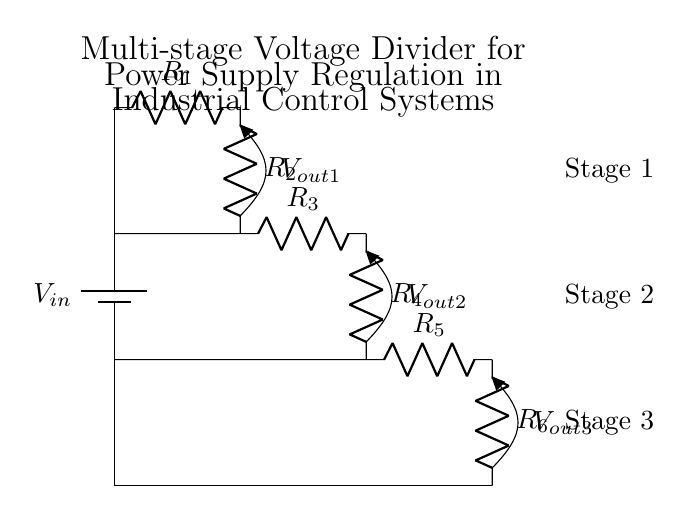What is the input voltage of the circuit? The input voltage is represented as V in, which is the source voltage supplied to the circuit.
Answer: V in How many resistors are used in the first stage? The first stage of the circuit contains two resistors, R1 and R2.
Answer: 2 What are the output voltage levels of this circuit? The output voltage levels are indicated at three points: V out1, V out2, and V out3 respectively, representing the voltage across the outputs after each stage.
Answer: V out1, V out2, V out3 Which stage has the highest output voltage? The highest output voltage will be in the first stage, as it is derived directly from the input voltage. The voltages decrease in subsequent stages due to the resistor voltage drops.
Answer: V out1 What is the total resistance of the entire voltage divider? To find the total resistance, we must add the resistances of all resistors in series. The equivalent resistance of the voltage divider is R1 + R2 + R3 + R4 + R5 + R6.
Answer: R1 + R2 + R3 + R4 + R5 + R6 How does the voltage at V out2 compare to V out1? V out2 will be less than V out1 because it is the result of a voltage drop across additional resistors (R3 and R4) after V out1 in the voltage divider configuration.
Answer: V out2 < V out1 What happens to V out3 as the load increases? As the load increases, V out3 will decrease due to a division of voltage across the additional load resistance in parallel with the last resistor stage (R5 and R6).
Answer: V out3 decreases 